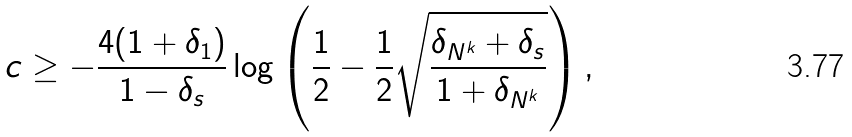<formula> <loc_0><loc_0><loc_500><loc_500>c \geq - \frac { 4 ( 1 + \delta _ { 1 } ) } { 1 - \delta _ { s } } \log \left ( \frac { 1 } { 2 } - \frac { 1 } { 2 } \sqrt { \frac { \delta _ { N ^ { k } } + \delta _ { s } } { 1 + \delta _ { N ^ { k } } } } \right ) ,</formula> 